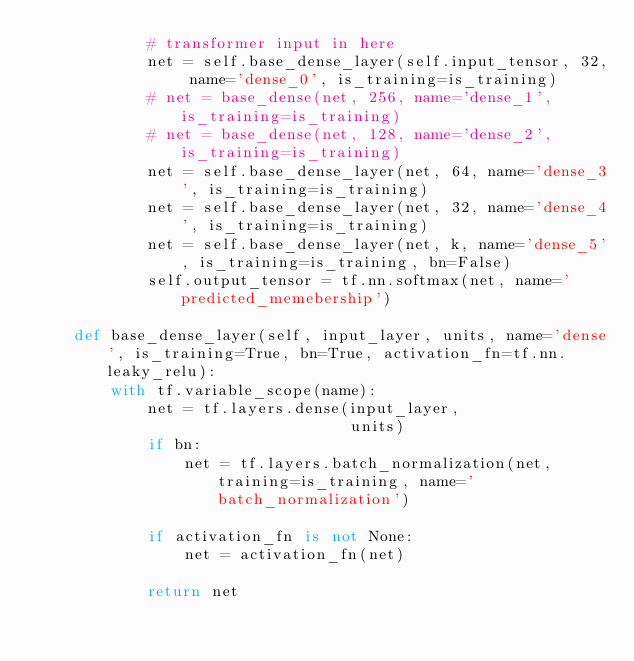<code> <loc_0><loc_0><loc_500><loc_500><_Python_>            # transformer input in here
            net = self.base_dense_layer(self.input_tensor, 32, name='dense_0', is_training=is_training)
            # net = base_dense(net, 256, name='dense_1', is_training=is_training)
            # net = base_dense(net, 128, name='dense_2', is_training=is_training)
            net = self.base_dense_layer(net, 64, name='dense_3', is_training=is_training)
            net = self.base_dense_layer(net, 32, name='dense_4', is_training=is_training)
            net = self.base_dense_layer(net, k, name='dense_5', is_training=is_training, bn=False)
            self.output_tensor = tf.nn.softmax(net, name='predicted_memebership')

    def base_dense_layer(self, input_layer, units, name='dense', is_training=True, bn=True, activation_fn=tf.nn.leaky_relu):
        with tf.variable_scope(name):
            net = tf.layers.dense(input_layer,
                                  units)
            if bn:
                net = tf.layers.batch_normalization(net, training=is_training, name='batch_normalization')

            if activation_fn is not None:
                net = activation_fn(net)

            return net</code> 